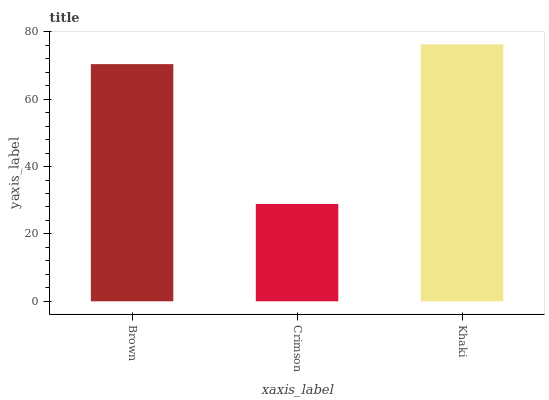Is Crimson the minimum?
Answer yes or no. Yes. Is Khaki the maximum?
Answer yes or no. Yes. Is Khaki the minimum?
Answer yes or no. No. Is Crimson the maximum?
Answer yes or no. No. Is Khaki greater than Crimson?
Answer yes or no. Yes. Is Crimson less than Khaki?
Answer yes or no. Yes. Is Crimson greater than Khaki?
Answer yes or no. No. Is Khaki less than Crimson?
Answer yes or no. No. Is Brown the high median?
Answer yes or no. Yes. Is Brown the low median?
Answer yes or no. Yes. Is Crimson the high median?
Answer yes or no. No. Is Khaki the low median?
Answer yes or no. No. 